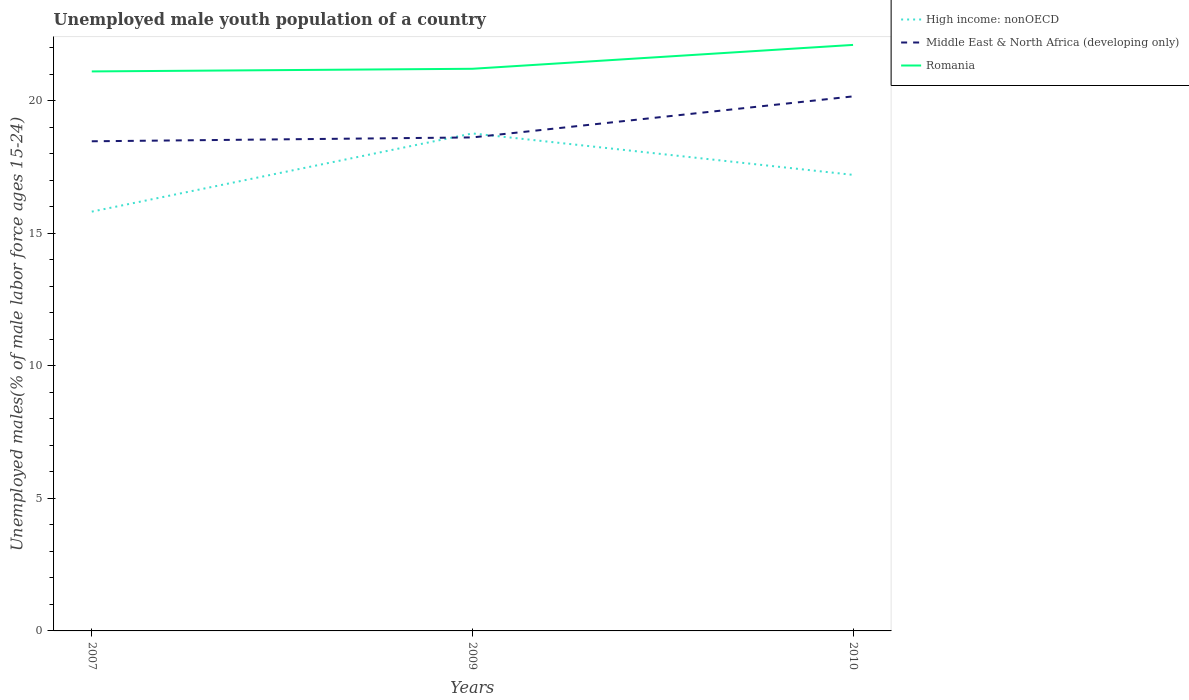Across all years, what is the maximum percentage of unemployed male youth population in High income: nonOECD?
Offer a very short reply. 15.81. In which year was the percentage of unemployed male youth population in High income: nonOECD maximum?
Make the answer very short. 2007. What is the total percentage of unemployed male youth population in High income: nonOECD in the graph?
Give a very brief answer. 1.56. What is the difference between the highest and the second highest percentage of unemployed male youth population in High income: nonOECD?
Offer a terse response. 2.95. What is the difference between the highest and the lowest percentage of unemployed male youth population in High income: nonOECD?
Your answer should be very brief. 1. How many years are there in the graph?
Your answer should be compact. 3. Where does the legend appear in the graph?
Offer a very short reply. Top right. What is the title of the graph?
Your answer should be compact. Unemployed male youth population of a country. Does "Papua New Guinea" appear as one of the legend labels in the graph?
Give a very brief answer. No. What is the label or title of the Y-axis?
Keep it short and to the point. Unemployed males(% of male labor force ages 15-24). What is the Unemployed males(% of male labor force ages 15-24) of High income: nonOECD in 2007?
Give a very brief answer. 15.81. What is the Unemployed males(% of male labor force ages 15-24) in Middle East & North Africa (developing only) in 2007?
Your response must be concise. 18.47. What is the Unemployed males(% of male labor force ages 15-24) of Romania in 2007?
Give a very brief answer. 21.1. What is the Unemployed males(% of male labor force ages 15-24) in High income: nonOECD in 2009?
Ensure brevity in your answer.  18.76. What is the Unemployed males(% of male labor force ages 15-24) of Middle East & North Africa (developing only) in 2009?
Provide a short and direct response. 18.61. What is the Unemployed males(% of male labor force ages 15-24) of Romania in 2009?
Provide a succinct answer. 21.2. What is the Unemployed males(% of male labor force ages 15-24) in High income: nonOECD in 2010?
Provide a short and direct response. 17.2. What is the Unemployed males(% of male labor force ages 15-24) of Middle East & North Africa (developing only) in 2010?
Ensure brevity in your answer.  20.16. What is the Unemployed males(% of male labor force ages 15-24) of Romania in 2010?
Keep it short and to the point. 22.1. Across all years, what is the maximum Unemployed males(% of male labor force ages 15-24) of High income: nonOECD?
Give a very brief answer. 18.76. Across all years, what is the maximum Unemployed males(% of male labor force ages 15-24) of Middle East & North Africa (developing only)?
Give a very brief answer. 20.16. Across all years, what is the maximum Unemployed males(% of male labor force ages 15-24) of Romania?
Your answer should be very brief. 22.1. Across all years, what is the minimum Unemployed males(% of male labor force ages 15-24) of High income: nonOECD?
Your answer should be very brief. 15.81. Across all years, what is the minimum Unemployed males(% of male labor force ages 15-24) of Middle East & North Africa (developing only)?
Your answer should be very brief. 18.47. Across all years, what is the minimum Unemployed males(% of male labor force ages 15-24) in Romania?
Offer a very short reply. 21.1. What is the total Unemployed males(% of male labor force ages 15-24) in High income: nonOECD in the graph?
Your answer should be very brief. 51.77. What is the total Unemployed males(% of male labor force ages 15-24) of Middle East & North Africa (developing only) in the graph?
Keep it short and to the point. 57.24. What is the total Unemployed males(% of male labor force ages 15-24) in Romania in the graph?
Your response must be concise. 64.4. What is the difference between the Unemployed males(% of male labor force ages 15-24) of High income: nonOECD in 2007 and that in 2009?
Your answer should be compact. -2.95. What is the difference between the Unemployed males(% of male labor force ages 15-24) of Middle East & North Africa (developing only) in 2007 and that in 2009?
Keep it short and to the point. -0.15. What is the difference between the Unemployed males(% of male labor force ages 15-24) of High income: nonOECD in 2007 and that in 2010?
Your answer should be compact. -1.39. What is the difference between the Unemployed males(% of male labor force ages 15-24) of Middle East & North Africa (developing only) in 2007 and that in 2010?
Provide a succinct answer. -1.69. What is the difference between the Unemployed males(% of male labor force ages 15-24) in High income: nonOECD in 2009 and that in 2010?
Offer a terse response. 1.56. What is the difference between the Unemployed males(% of male labor force ages 15-24) in Middle East & North Africa (developing only) in 2009 and that in 2010?
Provide a short and direct response. -1.55. What is the difference between the Unemployed males(% of male labor force ages 15-24) in High income: nonOECD in 2007 and the Unemployed males(% of male labor force ages 15-24) in Middle East & North Africa (developing only) in 2009?
Your answer should be compact. -2.8. What is the difference between the Unemployed males(% of male labor force ages 15-24) in High income: nonOECD in 2007 and the Unemployed males(% of male labor force ages 15-24) in Romania in 2009?
Provide a succinct answer. -5.39. What is the difference between the Unemployed males(% of male labor force ages 15-24) of Middle East & North Africa (developing only) in 2007 and the Unemployed males(% of male labor force ages 15-24) of Romania in 2009?
Keep it short and to the point. -2.73. What is the difference between the Unemployed males(% of male labor force ages 15-24) in High income: nonOECD in 2007 and the Unemployed males(% of male labor force ages 15-24) in Middle East & North Africa (developing only) in 2010?
Offer a very short reply. -4.35. What is the difference between the Unemployed males(% of male labor force ages 15-24) of High income: nonOECD in 2007 and the Unemployed males(% of male labor force ages 15-24) of Romania in 2010?
Your response must be concise. -6.29. What is the difference between the Unemployed males(% of male labor force ages 15-24) in Middle East & North Africa (developing only) in 2007 and the Unemployed males(% of male labor force ages 15-24) in Romania in 2010?
Your response must be concise. -3.63. What is the difference between the Unemployed males(% of male labor force ages 15-24) of High income: nonOECD in 2009 and the Unemployed males(% of male labor force ages 15-24) of Middle East & North Africa (developing only) in 2010?
Provide a short and direct response. -1.4. What is the difference between the Unemployed males(% of male labor force ages 15-24) of High income: nonOECD in 2009 and the Unemployed males(% of male labor force ages 15-24) of Romania in 2010?
Provide a short and direct response. -3.34. What is the difference between the Unemployed males(% of male labor force ages 15-24) in Middle East & North Africa (developing only) in 2009 and the Unemployed males(% of male labor force ages 15-24) in Romania in 2010?
Provide a succinct answer. -3.49. What is the average Unemployed males(% of male labor force ages 15-24) of High income: nonOECD per year?
Offer a very short reply. 17.26. What is the average Unemployed males(% of male labor force ages 15-24) of Middle East & North Africa (developing only) per year?
Offer a terse response. 19.08. What is the average Unemployed males(% of male labor force ages 15-24) in Romania per year?
Your answer should be very brief. 21.47. In the year 2007, what is the difference between the Unemployed males(% of male labor force ages 15-24) of High income: nonOECD and Unemployed males(% of male labor force ages 15-24) of Middle East & North Africa (developing only)?
Your answer should be compact. -2.65. In the year 2007, what is the difference between the Unemployed males(% of male labor force ages 15-24) of High income: nonOECD and Unemployed males(% of male labor force ages 15-24) of Romania?
Your answer should be compact. -5.29. In the year 2007, what is the difference between the Unemployed males(% of male labor force ages 15-24) of Middle East & North Africa (developing only) and Unemployed males(% of male labor force ages 15-24) of Romania?
Make the answer very short. -2.63. In the year 2009, what is the difference between the Unemployed males(% of male labor force ages 15-24) in High income: nonOECD and Unemployed males(% of male labor force ages 15-24) in Middle East & North Africa (developing only)?
Offer a terse response. 0.15. In the year 2009, what is the difference between the Unemployed males(% of male labor force ages 15-24) in High income: nonOECD and Unemployed males(% of male labor force ages 15-24) in Romania?
Offer a very short reply. -2.44. In the year 2009, what is the difference between the Unemployed males(% of male labor force ages 15-24) in Middle East & North Africa (developing only) and Unemployed males(% of male labor force ages 15-24) in Romania?
Offer a very short reply. -2.59. In the year 2010, what is the difference between the Unemployed males(% of male labor force ages 15-24) in High income: nonOECD and Unemployed males(% of male labor force ages 15-24) in Middle East & North Africa (developing only)?
Keep it short and to the point. -2.96. In the year 2010, what is the difference between the Unemployed males(% of male labor force ages 15-24) in High income: nonOECD and Unemployed males(% of male labor force ages 15-24) in Romania?
Ensure brevity in your answer.  -4.9. In the year 2010, what is the difference between the Unemployed males(% of male labor force ages 15-24) in Middle East & North Africa (developing only) and Unemployed males(% of male labor force ages 15-24) in Romania?
Your response must be concise. -1.94. What is the ratio of the Unemployed males(% of male labor force ages 15-24) in High income: nonOECD in 2007 to that in 2009?
Offer a terse response. 0.84. What is the ratio of the Unemployed males(% of male labor force ages 15-24) in Middle East & North Africa (developing only) in 2007 to that in 2009?
Give a very brief answer. 0.99. What is the ratio of the Unemployed males(% of male labor force ages 15-24) of High income: nonOECD in 2007 to that in 2010?
Make the answer very short. 0.92. What is the ratio of the Unemployed males(% of male labor force ages 15-24) of Middle East & North Africa (developing only) in 2007 to that in 2010?
Keep it short and to the point. 0.92. What is the ratio of the Unemployed males(% of male labor force ages 15-24) of Romania in 2007 to that in 2010?
Offer a terse response. 0.95. What is the ratio of the Unemployed males(% of male labor force ages 15-24) in Middle East & North Africa (developing only) in 2009 to that in 2010?
Offer a terse response. 0.92. What is the ratio of the Unemployed males(% of male labor force ages 15-24) in Romania in 2009 to that in 2010?
Provide a short and direct response. 0.96. What is the difference between the highest and the second highest Unemployed males(% of male labor force ages 15-24) in High income: nonOECD?
Your answer should be compact. 1.56. What is the difference between the highest and the second highest Unemployed males(% of male labor force ages 15-24) of Middle East & North Africa (developing only)?
Provide a succinct answer. 1.55. What is the difference between the highest and the second highest Unemployed males(% of male labor force ages 15-24) in Romania?
Keep it short and to the point. 0.9. What is the difference between the highest and the lowest Unemployed males(% of male labor force ages 15-24) in High income: nonOECD?
Provide a short and direct response. 2.95. What is the difference between the highest and the lowest Unemployed males(% of male labor force ages 15-24) in Middle East & North Africa (developing only)?
Provide a short and direct response. 1.69. What is the difference between the highest and the lowest Unemployed males(% of male labor force ages 15-24) of Romania?
Provide a succinct answer. 1. 